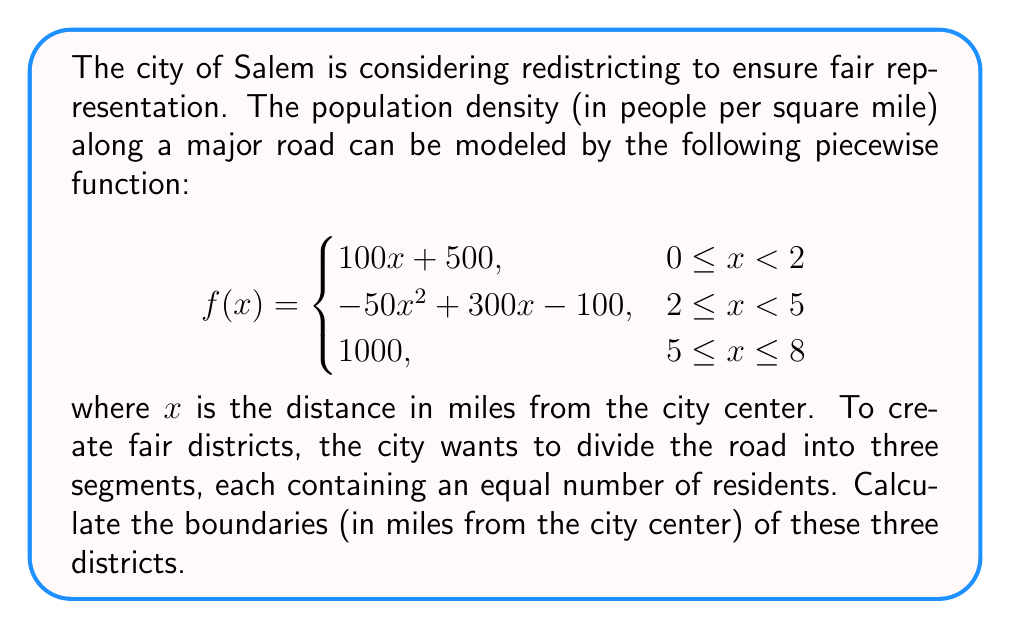Help me with this question. To solve this problem, we need to follow these steps:

1) Calculate the total population along the road by integrating the piecewise function over the entire domain [0, 8].

2) Divide the total population by 3 to determine the population for each district.

3) Find the boundaries by integrating the function and solving for x when the integral equals 1/3 and 2/3 of the total population.

Step 1: Calculate total population

$$\text{Total Population} = \int_0^2 (100x + 500) dx + \int_2^5 (-50x^2 + 300x - 100) dx + \int_5^8 1000 dx$$

$$= [50x^2 + 500x]_0^2 + [-\frac{50}{3}x^3 + 150x^2 - 100x]_2^5 + [1000x]_5^8$$

$$= (200 + 1000) + ((-2083.33 + 3750 - 500) - (-133.33 + 600 - 200)) + 3000$$

$$= 1200 + 933.33 + 3000 = 5133.33$$

Step 2: Population per district

$$\text{Population per district} = 5133.33 / 3 = 1711.11$$

Step 3: Find boundaries

For the first boundary (x₁):

$$\int_0^{x_1} (100x + 500) dx = 1711.11$$

$$[50x^2 + 500x]_0^{x_1} = 1711.11$$

$$50x_1^2 + 500x_1 = 1711.11$$

Solving this quadratic equation: $x_1 \approx 2.29$ miles

For the second boundary (x₂):

$$\int_0^2 (100x + 500) dx + \int_2^{x_2} (-50x^2 + 300x - 100) dx = 2 * 1711.11 = 3422.22$$

$$1200 + [-\frac{50}{3}x^3 + 150x^2 - 100x]_2^{x_2} = 3422.22$$

Solving this equation numerically: $x_2 \approx 5.37$ miles

The third boundary is at 8 miles, the end of the road.
Answer: The fair district boundaries are approximately 2.29 miles, 5.37 miles, and 8 miles from the city center. 